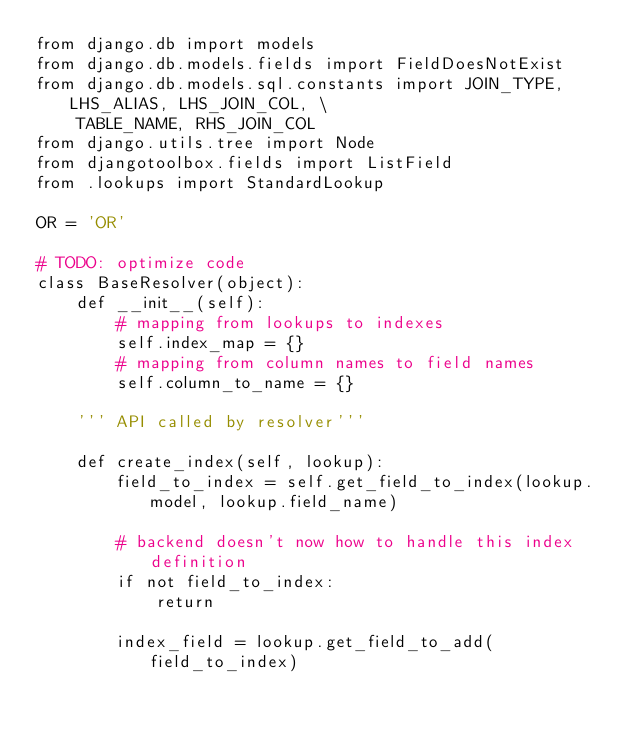Convert code to text. <code><loc_0><loc_0><loc_500><loc_500><_Python_>from django.db import models
from django.db.models.fields import FieldDoesNotExist
from django.db.models.sql.constants import JOIN_TYPE, LHS_ALIAS, LHS_JOIN_COL, \
    TABLE_NAME, RHS_JOIN_COL
from django.utils.tree import Node
from djangotoolbox.fields import ListField
from .lookups import StandardLookup

OR = 'OR'

# TODO: optimize code
class BaseResolver(object):
    def __init__(self):
        # mapping from lookups to indexes
        self.index_map = {}
        # mapping from column names to field names
        self.column_to_name = {}

    ''' API called by resolver'''

    def create_index(self, lookup):
        field_to_index = self.get_field_to_index(lookup.model, lookup.field_name)

        # backend doesn't now how to handle this index definition
        if not field_to_index:
            return

        index_field = lookup.get_field_to_add(field_to_index)</code> 